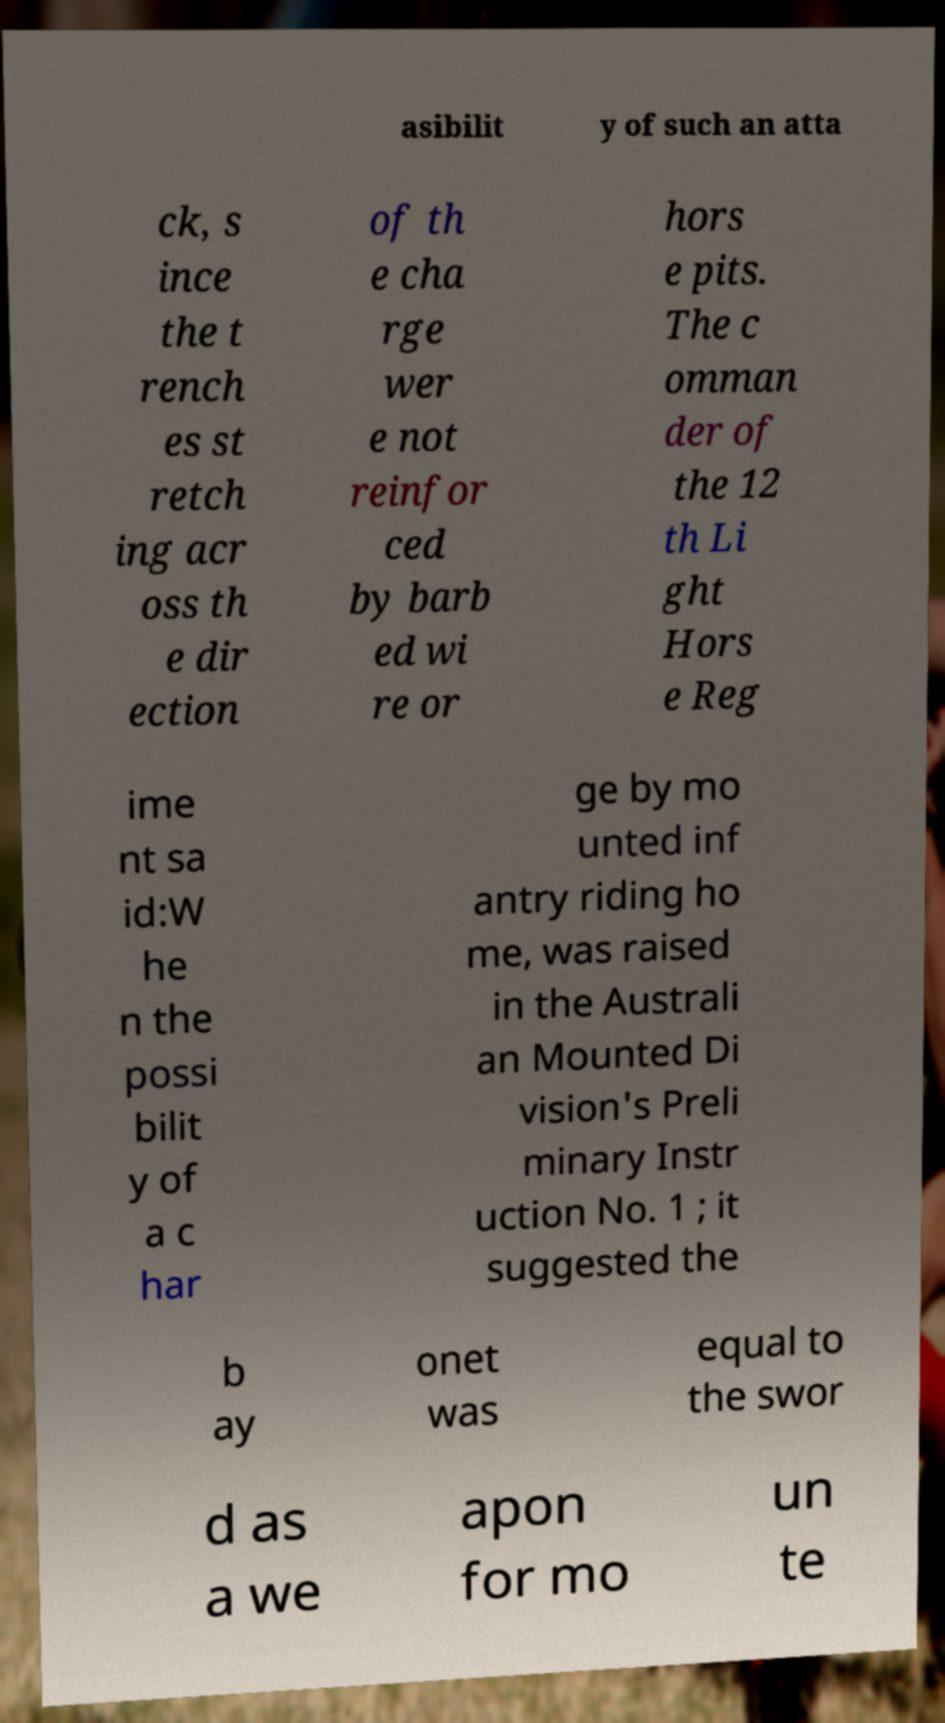Could you extract and type out the text from this image? asibilit y of such an atta ck, s ince the t rench es st retch ing acr oss th e dir ection of th e cha rge wer e not reinfor ced by barb ed wi re or hors e pits. The c omman der of the 12 th Li ght Hors e Reg ime nt sa id:W he n the possi bilit y of a c har ge by mo unted inf antry riding ho me, was raised in the Australi an Mounted Di vision's Preli minary Instr uction No. 1 ; it suggested the b ay onet was equal to the swor d as a we apon for mo un te 